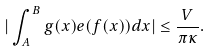Convert formula to latex. <formula><loc_0><loc_0><loc_500><loc_500>| \int _ { A } ^ { B } g ( x ) e ( f ( x ) ) d x | \leq \frac { V } { \pi \kappa } .</formula> 